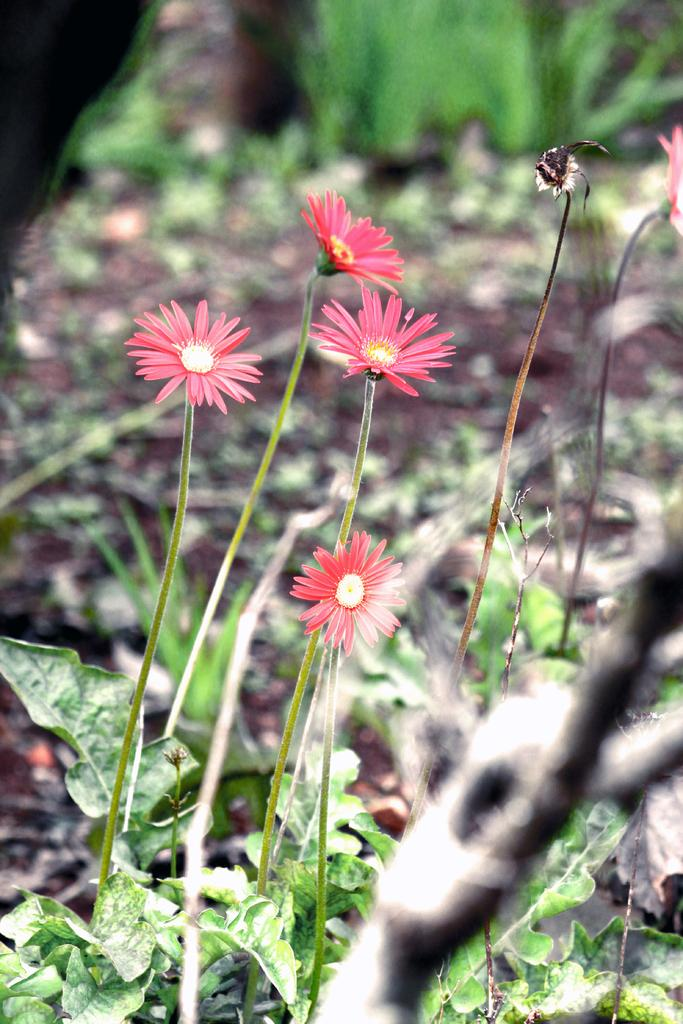What type of plants can be seen in the image? There are flowers in the image. What other part of the plants can be seen in the image? There are leaves in the image. Can you describe the background of the image? The background of the image is blurry. What season is depicted in the image? The provided facts do not specify a season, so it cannot be determined from the image. 